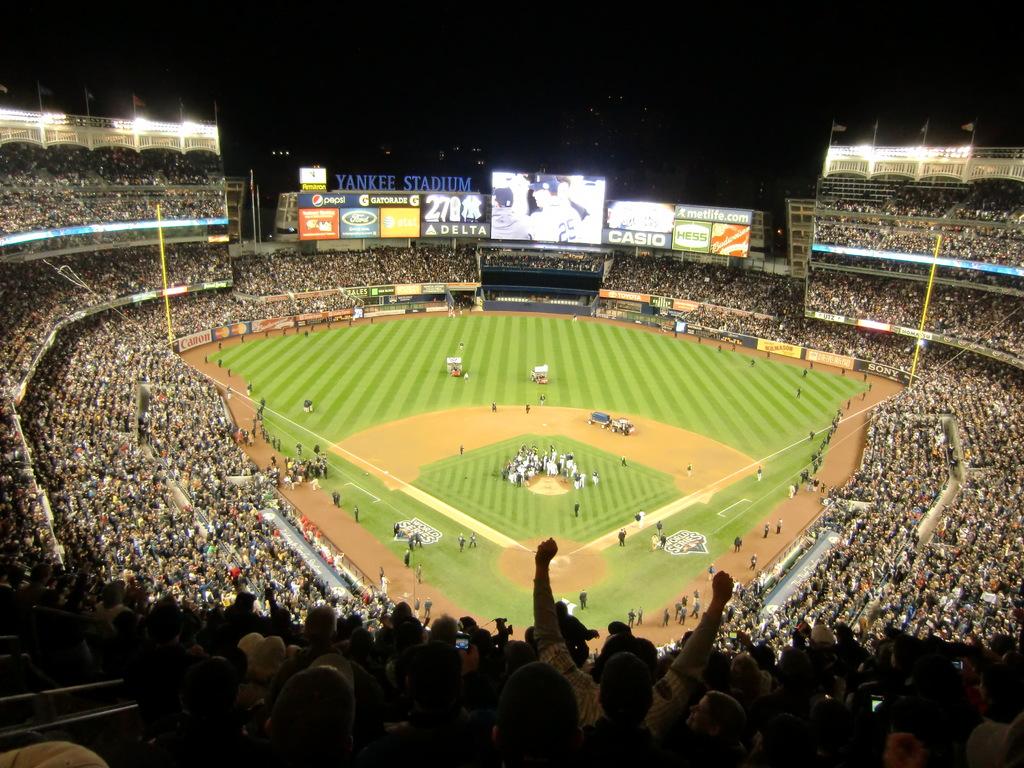What is the name of the stadium?
Ensure brevity in your answer.  Yankee stadium. What website is being advertised?
Keep it short and to the point. Metlife.com. 